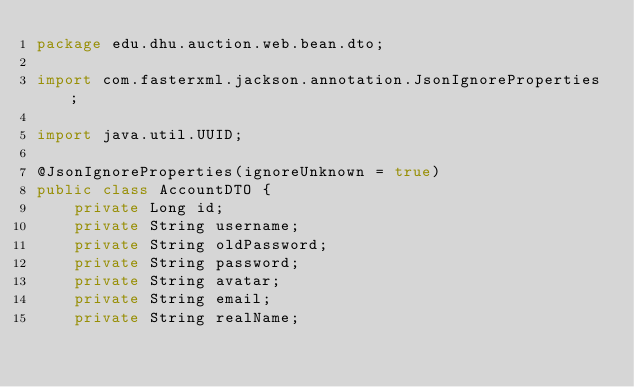Convert code to text. <code><loc_0><loc_0><loc_500><loc_500><_Java_>package edu.dhu.auction.web.bean.dto;

import com.fasterxml.jackson.annotation.JsonIgnoreProperties;

import java.util.UUID;

@JsonIgnoreProperties(ignoreUnknown = true)
public class AccountDTO {
    private Long id;
    private String username;
    private String oldPassword;
    private String password;
    private String avatar;
    private String email;
    private String realName;</code> 